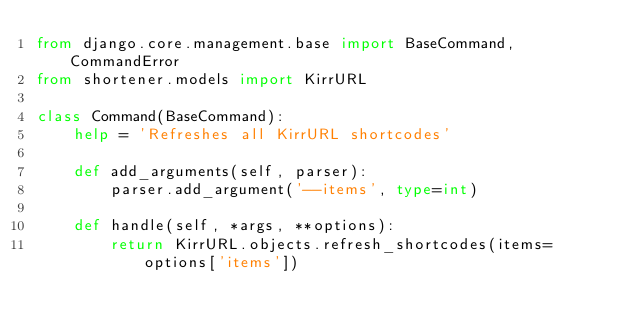<code> <loc_0><loc_0><loc_500><loc_500><_Python_>from django.core.management.base import BaseCommand, CommandError
from shortener.models import KirrURL

class Command(BaseCommand):
    help = 'Refreshes all KirrURL shortcodes'

    def add_arguments(self, parser):
        parser.add_argument('--items', type=int)

    def handle(self, *args, **options):
        return KirrURL.objects.refresh_shortcodes(items=options['items'])
</code> 